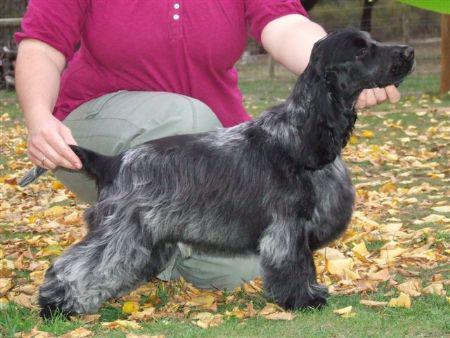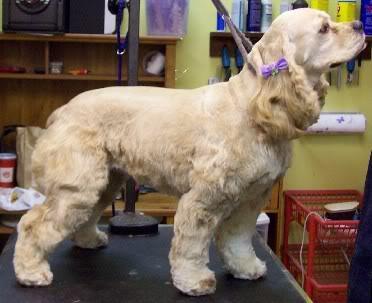The first image is the image on the left, the second image is the image on the right. Given the left and right images, does the statement "A person is tending to the dog in one of the images." hold true? Answer yes or no. Yes. 